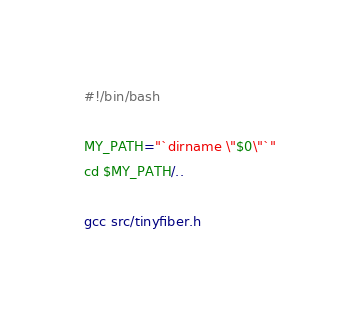<code> <loc_0><loc_0><loc_500><loc_500><_Bash_>#!/bin/bash

MY_PATH="`dirname \"$0\"`"
cd $MY_PATH/..

gcc src/tinyfiber.h
</code> 